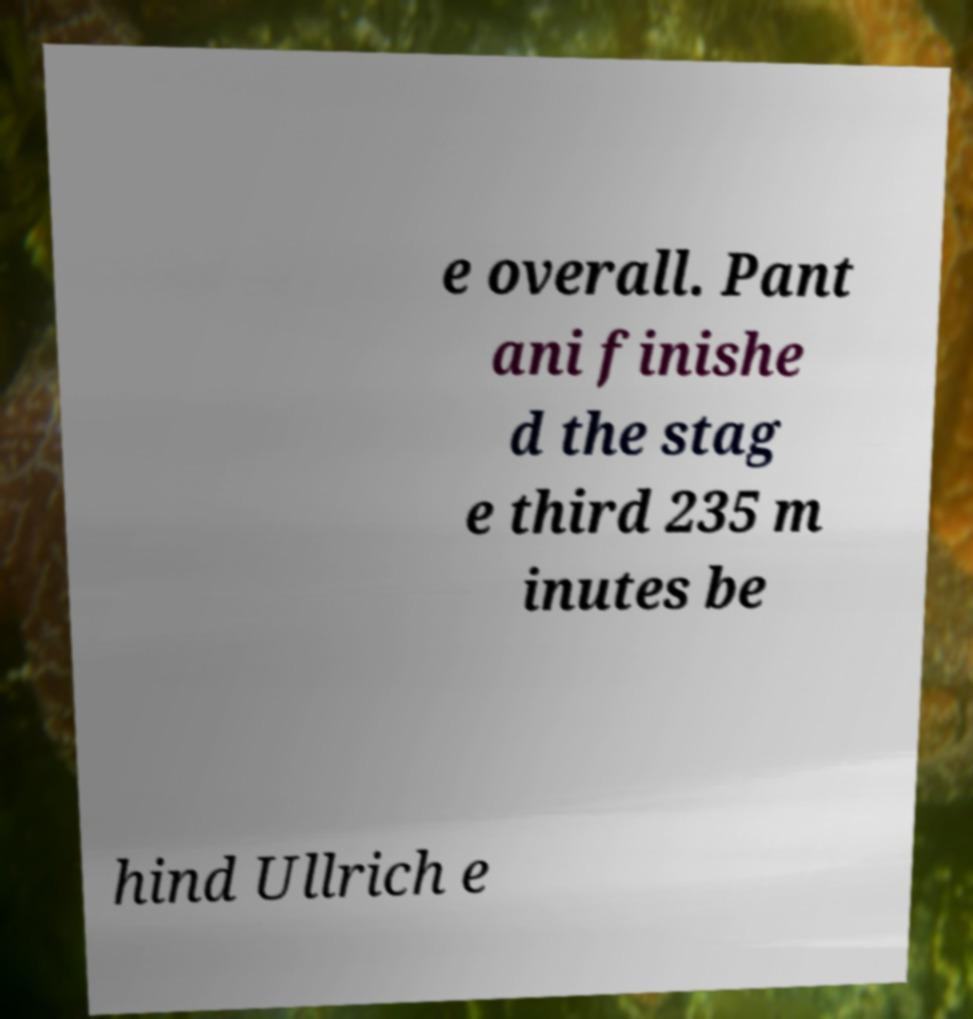For documentation purposes, I need the text within this image transcribed. Could you provide that? e overall. Pant ani finishe d the stag e third 235 m inutes be hind Ullrich e 